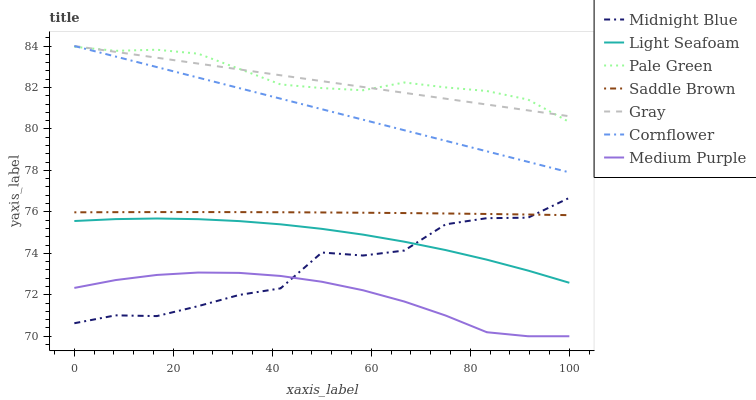Does Medium Purple have the minimum area under the curve?
Answer yes or no. Yes. Does Pale Green have the maximum area under the curve?
Answer yes or no. Yes. Does Midnight Blue have the minimum area under the curve?
Answer yes or no. No. Does Midnight Blue have the maximum area under the curve?
Answer yes or no. No. Is Gray the smoothest?
Answer yes or no. Yes. Is Midnight Blue the roughest?
Answer yes or no. Yes. Is Midnight Blue the smoothest?
Answer yes or no. No. Is Gray the roughest?
Answer yes or no. No. Does Midnight Blue have the lowest value?
Answer yes or no. No. Does Gray have the highest value?
Answer yes or no. Yes. Does Midnight Blue have the highest value?
Answer yes or no. No. Is Medium Purple less than Saddle Brown?
Answer yes or no. Yes. Is Gray greater than Saddle Brown?
Answer yes or no. Yes. Does Gray intersect Cornflower?
Answer yes or no. Yes. Is Gray less than Cornflower?
Answer yes or no. No. Is Gray greater than Cornflower?
Answer yes or no. No. Does Medium Purple intersect Saddle Brown?
Answer yes or no. No. 